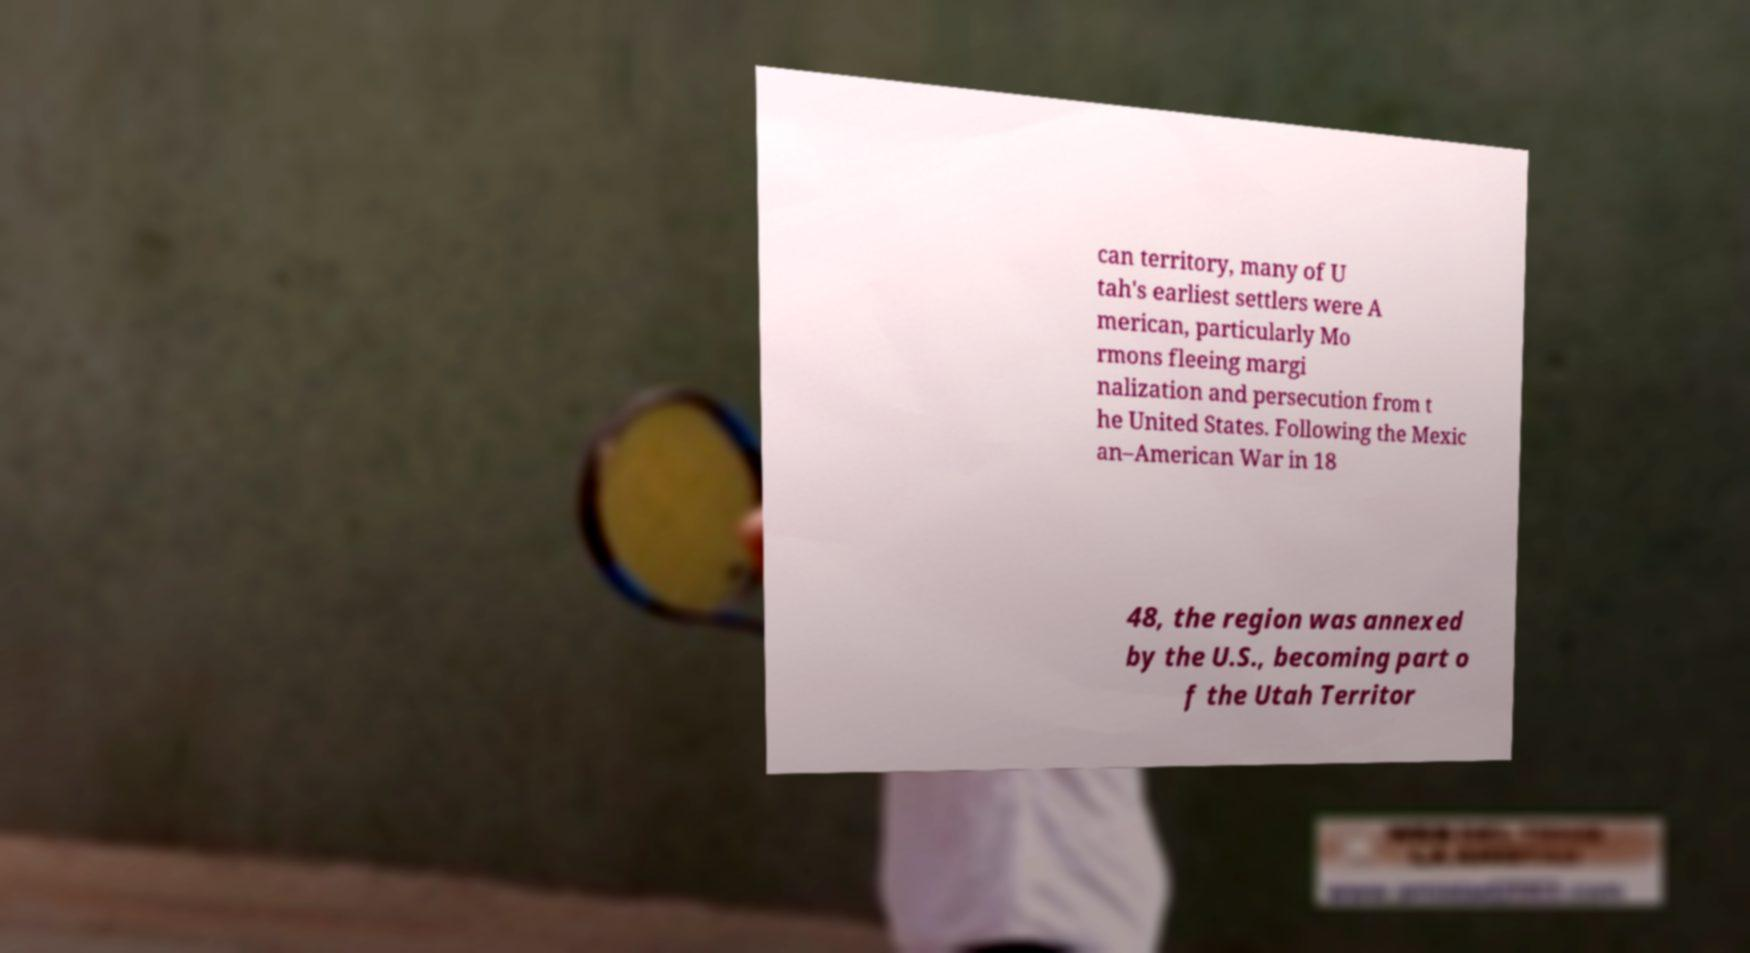What messages or text are displayed in this image? I need them in a readable, typed format. can territory, many of U tah's earliest settlers were A merican, particularly Mo rmons fleeing margi nalization and persecution from t he United States. Following the Mexic an–American War in 18 48, the region was annexed by the U.S., becoming part o f the Utah Territor 